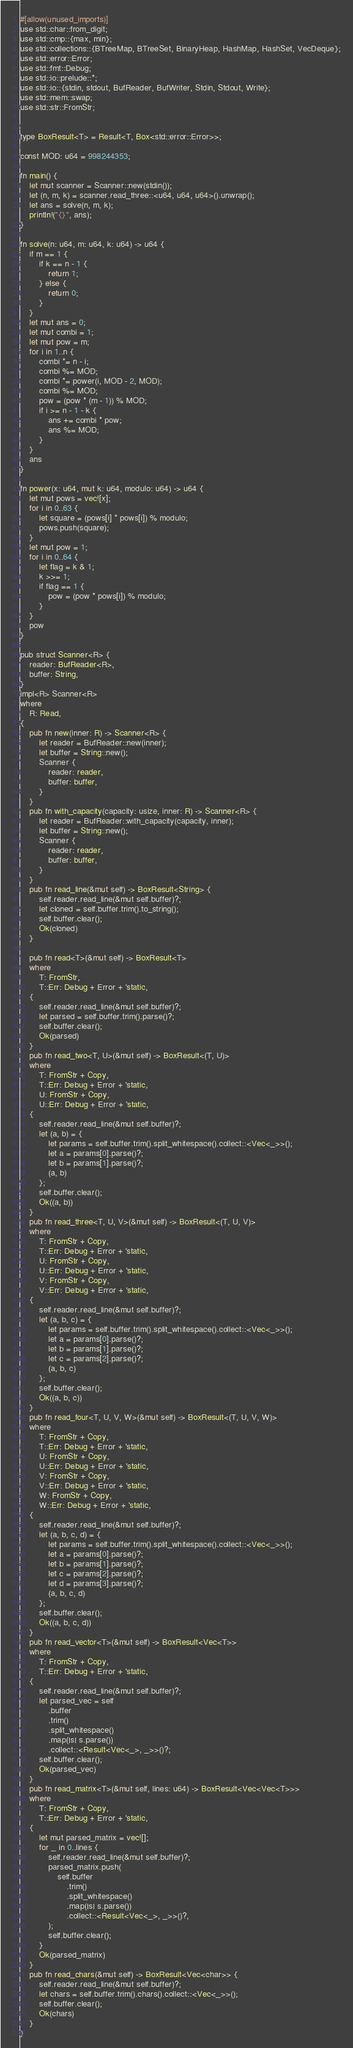<code> <loc_0><loc_0><loc_500><loc_500><_Rust_>#[allow(unused_imports)]
use std::char::from_digit;
use std::cmp::{max, min};
use std::collections::{BTreeMap, BTreeSet, BinaryHeap, HashMap, HashSet, VecDeque};
use std::error::Error;
use std::fmt::Debug;
use std::io::prelude::*;
use std::io::{stdin, stdout, BufReader, BufWriter, Stdin, Stdout, Write};
use std::mem::swap;
use std::str::FromStr;


type BoxResult<T> = Result<T, Box<std::error::Error>>;

const MOD: u64 = 998244353;

fn main() {
    let mut scanner = Scanner::new(stdin());
    let (n, m, k) = scanner.read_three::<u64, u64, u64>().unwrap();
    let ans = solve(n, m, k);
    println!("{}", ans);
}

fn solve(n: u64, m: u64, k: u64) -> u64 {
    if m == 1 {
        if k == n - 1 {
            return 1;
        } else {
            return 0;
        }
    }
    let mut ans = 0;
    let mut combi = 1;
    let mut pow = m;
    for i in 1..n {
        combi *= n - i;
        combi %= MOD;
        combi *= power(i, MOD - 2, MOD);
        combi %= MOD;
        pow = (pow * (m - 1)) % MOD;
        if i >= n - 1 - k {
            ans += combi * pow;
            ans %= MOD;
        }
    }
    ans
}

fn power(x: u64, mut k: u64, modulo: u64) -> u64 {
    let mut pows = vec![x];
    for i in 0..63 {
        let square = (pows[i] * pows[i]) % modulo;
        pows.push(square);
    }
    let mut pow = 1;
    for i in 0..64 {
        let flag = k & 1;
        k >>= 1;
        if flag == 1 {
            pow = (pow * pows[i]) % modulo;
        }
    }
    pow
}

pub struct Scanner<R> {
    reader: BufReader<R>,
    buffer: String,
}
impl<R> Scanner<R>
where
    R: Read,
{
    pub fn new(inner: R) -> Scanner<R> {
        let reader = BufReader::new(inner);
        let buffer = String::new();
        Scanner {
            reader: reader,
            buffer: buffer,
        }
    }
    pub fn with_capacity(capacity: usize, inner: R) -> Scanner<R> {
        let reader = BufReader::with_capacity(capacity, inner);
        let buffer = String::new();
        Scanner {
            reader: reader,
            buffer: buffer,
        }
    }
    pub fn read_line(&mut self) -> BoxResult<String> {
        self.reader.read_line(&mut self.buffer)?;
        let cloned = self.buffer.trim().to_string();
        self.buffer.clear();
        Ok(cloned)
    }

    pub fn read<T>(&mut self) -> BoxResult<T>
    where
        T: FromStr,
        T::Err: Debug + Error + 'static,
    {
        self.reader.read_line(&mut self.buffer)?;
        let parsed = self.buffer.trim().parse()?;
        self.buffer.clear();
        Ok(parsed)
    }
    pub fn read_two<T, U>(&mut self) -> BoxResult<(T, U)>
    where
        T: FromStr + Copy,
        T::Err: Debug + Error + 'static,
        U: FromStr + Copy,
        U::Err: Debug + Error + 'static,
    {
        self.reader.read_line(&mut self.buffer)?;
        let (a, b) = {
            let params = self.buffer.trim().split_whitespace().collect::<Vec<_>>();
            let a = params[0].parse()?;
            let b = params[1].parse()?;
            (a, b)
        };
        self.buffer.clear();
        Ok((a, b))
    }
    pub fn read_three<T, U, V>(&mut self) -> BoxResult<(T, U, V)>
    where
        T: FromStr + Copy,
        T::Err: Debug + Error + 'static,
        U: FromStr + Copy,
        U::Err: Debug + Error + 'static,
        V: FromStr + Copy,
        V::Err: Debug + Error + 'static,
    {
        self.reader.read_line(&mut self.buffer)?;
        let (a, b, c) = {
            let params = self.buffer.trim().split_whitespace().collect::<Vec<_>>();
            let a = params[0].parse()?;
            let b = params[1].parse()?;
            let c = params[2].parse()?;
            (a, b, c)
        };
        self.buffer.clear();
        Ok((a, b, c))
    }
    pub fn read_four<T, U, V, W>(&mut self) -> BoxResult<(T, U, V, W)>
    where
        T: FromStr + Copy,
        T::Err: Debug + Error + 'static,
        U: FromStr + Copy,
        U::Err: Debug + Error + 'static,
        V: FromStr + Copy,
        V::Err: Debug + Error + 'static,
        W: FromStr + Copy,
        W::Err: Debug + Error + 'static,
    {
        self.reader.read_line(&mut self.buffer)?;
        let (a, b, c, d) = {
            let params = self.buffer.trim().split_whitespace().collect::<Vec<_>>();
            let a = params[0].parse()?;
            let b = params[1].parse()?;
            let c = params[2].parse()?;
            let d = params[3].parse()?;
            (a, b, c, d)
        };
        self.buffer.clear();
        Ok((a, b, c, d))
    }
    pub fn read_vector<T>(&mut self) -> BoxResult<Vec<T>>
    where
        T: FromStr + Copy,
        T::Err: Debug + Error + 'static,
    {
        self.reader.read_line(&mut self.buffer)?;
        let parsed_vec = self
            .buffer
            .trim()
            .split_whitespace()
            .map(|s| s.parse())
            .collect::<Result<Vec<_>, _>>()?;
        self.buffer.clear();
        Ok(parsed_vec)
    }
    pub fn read_matrix<T>(&mut self, lines: u64) -> BoxResult<Vec<Vec<T>>>
    where
        T: FromStr + Copy,
        T::Err: Debug + Error + 'static,
    {
        let mut parsed_matrix = vec![];
        for _ in 0..lines {
            self.reader.read_line(&mut self.buffer)?;
            parsed_matrix.push(
                self.buffer
                    .trim()
                    .split_whitespace()
                    .map(|s| s.parse())
                    .collect::<Result<Vec<_>, _>>()?,
            );
            self.buffer.clear();
        }
        Ok(parsed_matrix)
    }
    pub fn read_chars(&mut self) -> BoxResult<Vec<char>> {
        self.reader.read_line(&mut self.buffer)?;
        let chars = self.buffer.trim().chars().collect::<Vec<_>>();
        self.buffer.clear();
        Ok(chars)
    }
}
</code> 